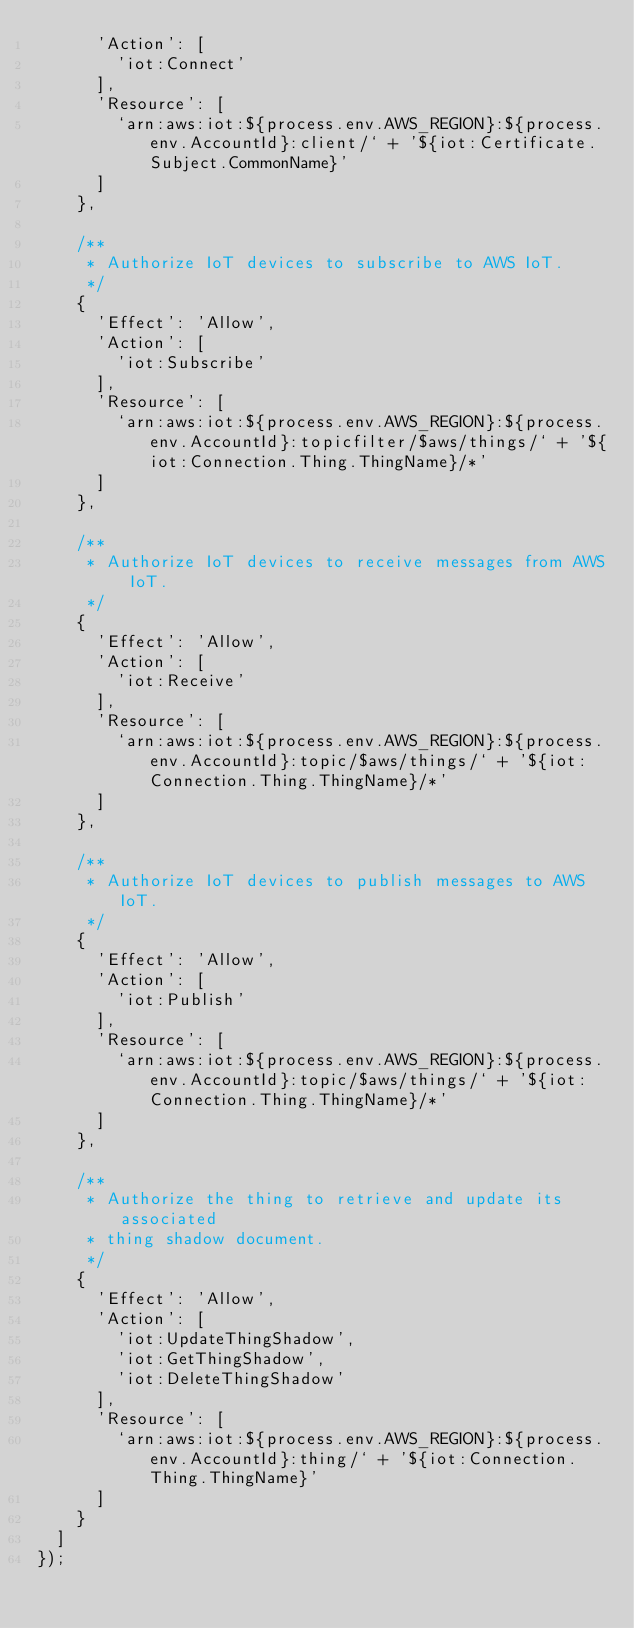Convert code to text. <code><loc_0><loc_0><loc_500><loc_500><_JavaScript_>      'Action': [
        'iot:Connect'
      ],
      'Resource': [
        `arn:aws:iot:${process.env.AWS_REGION}:${process.env.AccountId}:client/` + '${iot:Certificate.Subject.CommonName}'
      ]
    },

    /**
     * Authorize IoT devices to subscribe to AWS IoT.
     */
    {
      'Effect': 'Allow',
      'Action': [
        'iot:Subscribe'
      ],
      'Resource': [
        `arn:aws:iot:${process.env.AWS_REGION}:${process.env.AccountId}:topicfilter/$aws/things/` + '${iot:Connection.Thing.ThingName}/*'
      ]
    },

    /**
     * Authorize IoT devices to receive messages from AWS IoT.
     */
    {
      'Effect': 'Allow',
      'Action': [
        'iot:Receive'
      ],
      'Resource': [
        `arn:aws:iot:${process.env.AWS_REGION}:${process.env.AccountId}:topic/$aws/things/` + '${iot:Connection.Thing.ThingName}/*'
      ]
    },

    /**
     * Authorize IoT devices to publish messages to AWS IoT.
     */
    {
      'Effect': 'Allow',
      'Action': [
        'iot:Publish'
      ],
      'Resource': [
        `arn:aws:iot:${process.env.AWS_REGION}:${process.env.AccountId}:topic/$aws/things/` + '${iot:Connection.Thing.ThingName}/*'
      ]
    },

    /**
     * Authorize the thing to retrieve and update its associated
     * thing shadow document.
     */
    {
      'Effect': 'Allow',
      'Action': [
        'iot:UpdateThingShadow',
        'iot:GetThingShadow',
        'iot:DeleteThingShadow'
      ],
      'Resource': [
        `arn:aws:iot:${process.env.AWS_REGION}:${process.env.AccountId}:thing/` + '${iot:Connection.Thing.ThingName}'
      ]
    }
  ]
});</code> 